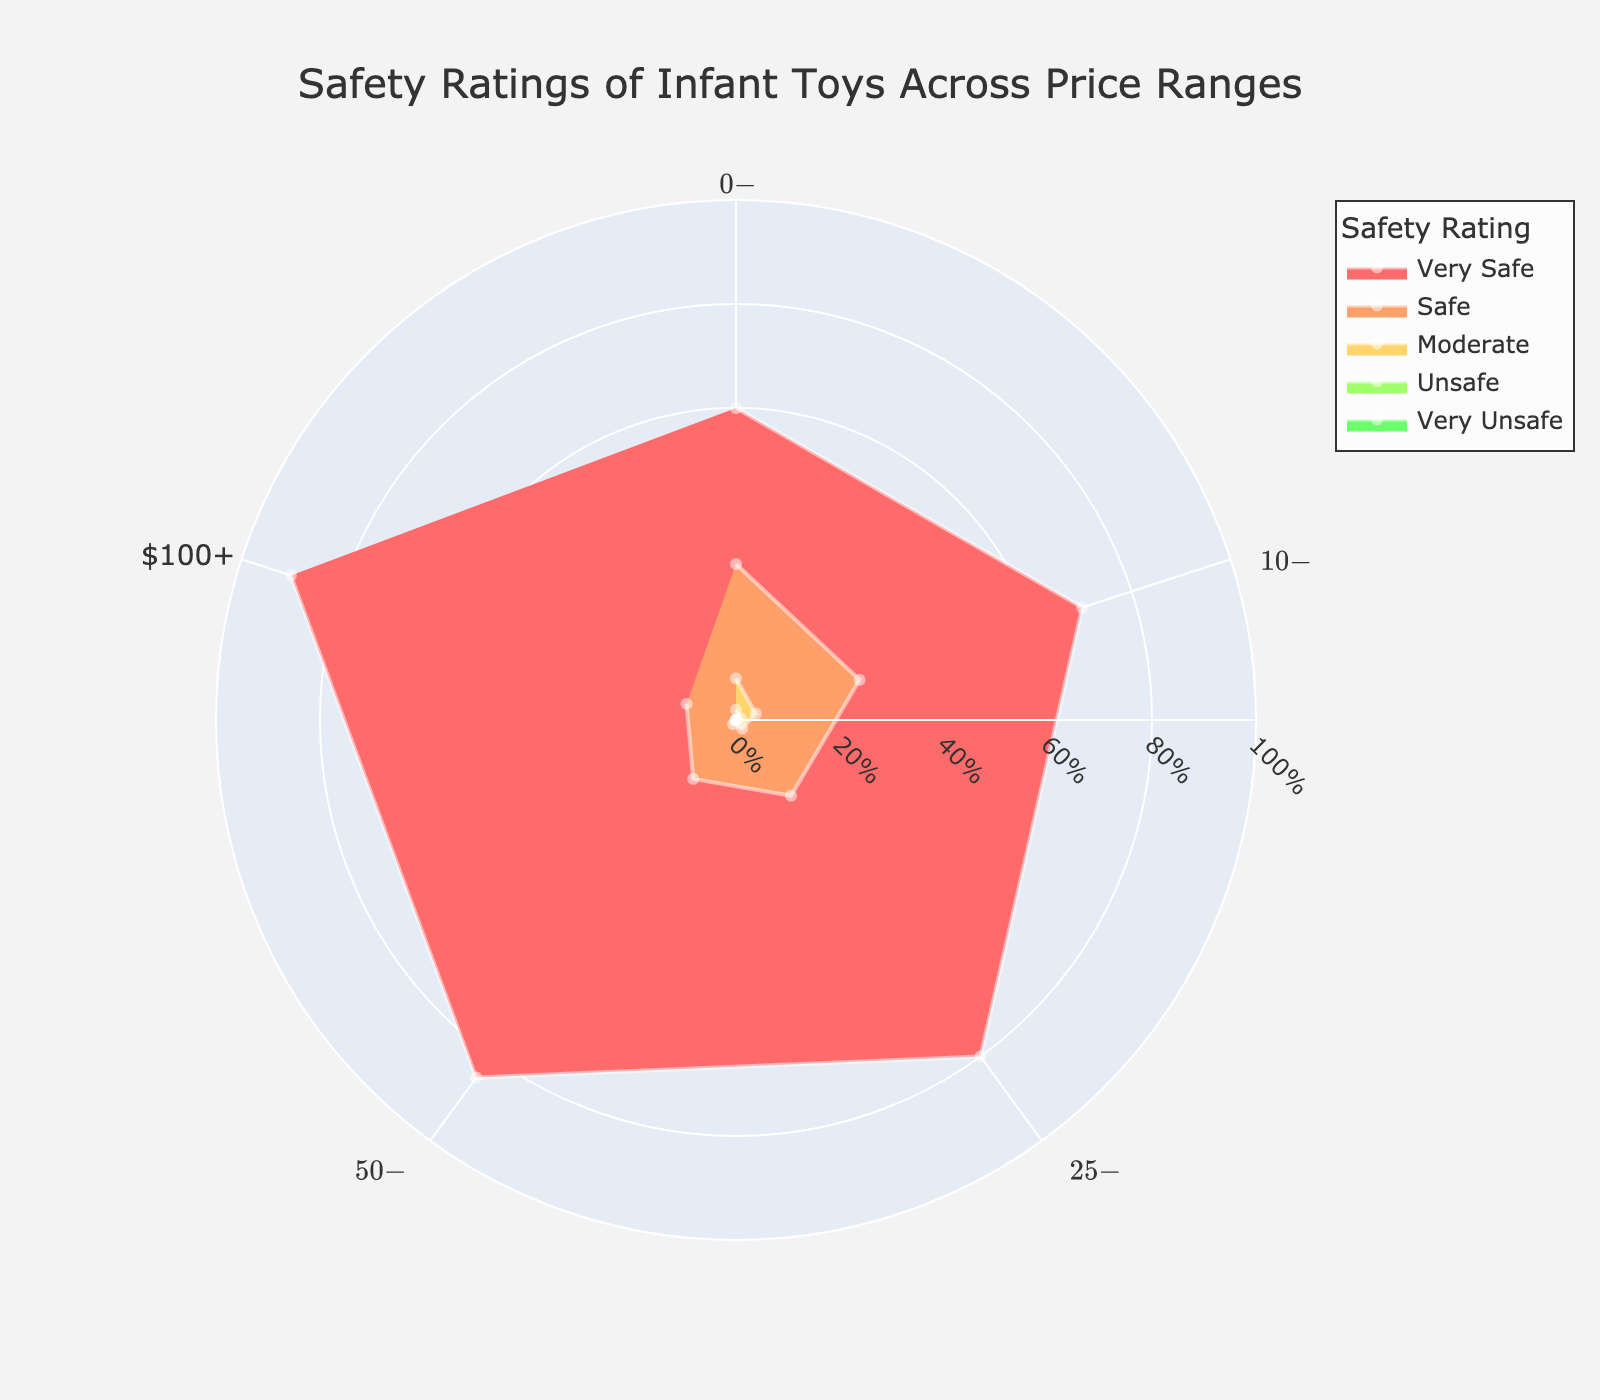How many price ranges are shown in the chart? The chart has distinct price ranges displayed, and we can count them.
Answer: 5 Which safety rating has the highest percentage in the $0-$10 price range? Observe the "Very Safe" percentage for the $0-$10 price range and compare it against other safety ratings.
Answer: Very Safe What is the trend in the percentage of "Unsafe" toys as the price range increases? Identify the "Unsafe" category percentages across each price range and note the directional pattern.
Answer: Decreases In which price range does the "Safe" rating have the highest percentage? Inspect each price range's "Safe" rating to find the maximum percentage.
Answer: $0-$10 How many total categories of safety ratings are there on the chart? There are distinct categories for safety ratings shown in the legend. Count these categories.
Answer: 5 What is the combined percentage of "Very Safe" and "Safe" ratings for the $25-$50 price range? Sum the percentages of "Very Safe" and "Safe" under the $25-$50 category (80% + 18%).
Answer: 98% Which price range has the lowest percentage of "Moderate" rated toys? Look at each price range's "Moderate" rating percentage and find the lowest one.
Answer: $100+ How does the percentage of "Very Safe" toys change as the price range increases from $0-$10 to $100+? Track the percentages of "Very Safe" toys for each ascending price range.
Answer: Increases Between the $10-$25 and $50-$100 price ranges, which one has a higher percentage of "Very Unsafe" toys? Compare the "Very Unsafe" toy percentages in the $10-$25 and $50-$100 price ranges.
Answer: $10-$25 What is the difference in the "Very Safe" rating percentages between the $0-$10 and $100+ price ranges? Subtract the "Very Safe" rating percentage of the $0-$10 range from that of the $100+ range (90% - 60%).
Answer: 30% 